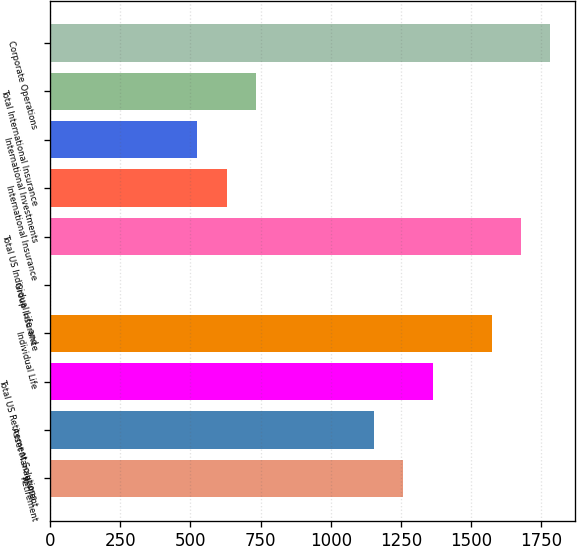Convert chart to OTSL. <chart><loc_0><loc_0><loc_500><loc_500><bar_chart><fcel>Retirement<fcel>Asset Management<fcel>Total US Retirement Solutions<fcel>Individual Life<fcel>Group Insurance<fcel>Total US Individual Life and<fcel>International Insurance<fcel>International Investments<fcel>Total International Insurance<fcel>Corporate Operations<nl><fcel>1258.65<fcel>1153.84<fcel>1363.46<fcel>1573.08<fcel>0.93<fcel>1677.89<fcel>629.79<fcel>524.98<fcel>734.6<fcel>1782.7<nl></chart> 